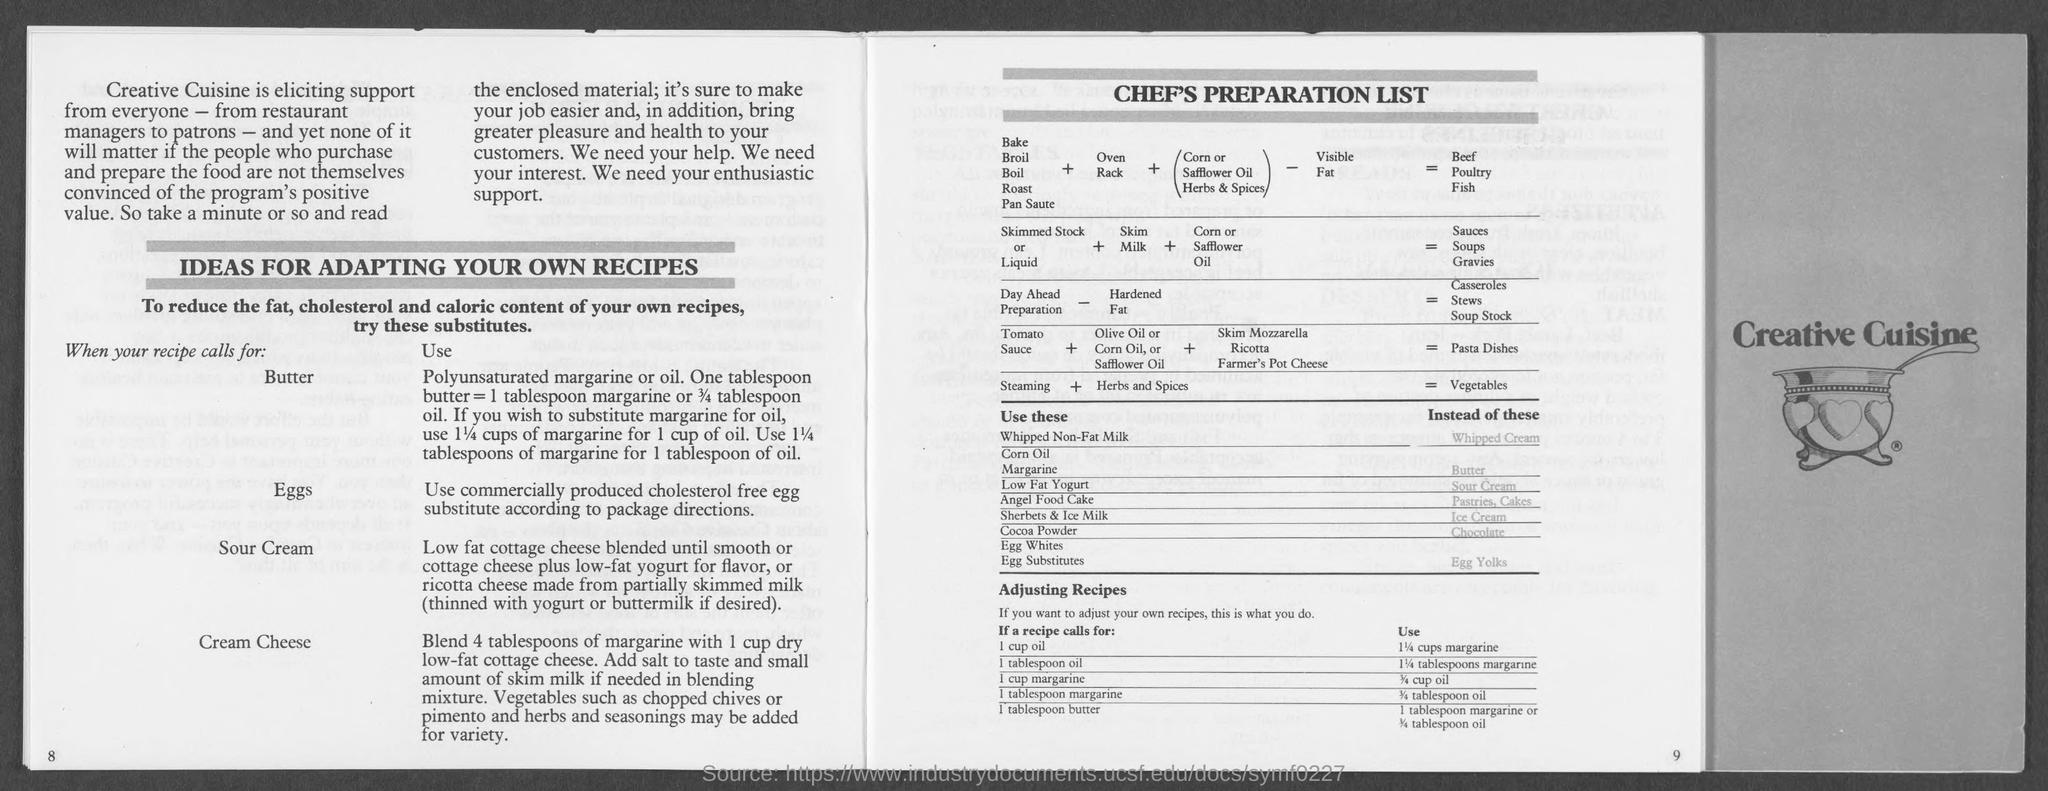What is the ideas for?
Give a very brief answer. Adapting your own recipes. What is one tablespoon butter is equal to?
Make the answer very short. 1 tablespoon margarine or 3/4 tablespoon oil. What should be used if a recipe calls for 1 cup oil?
Provide a succinct answer. 1 1/4 cups margarine. 